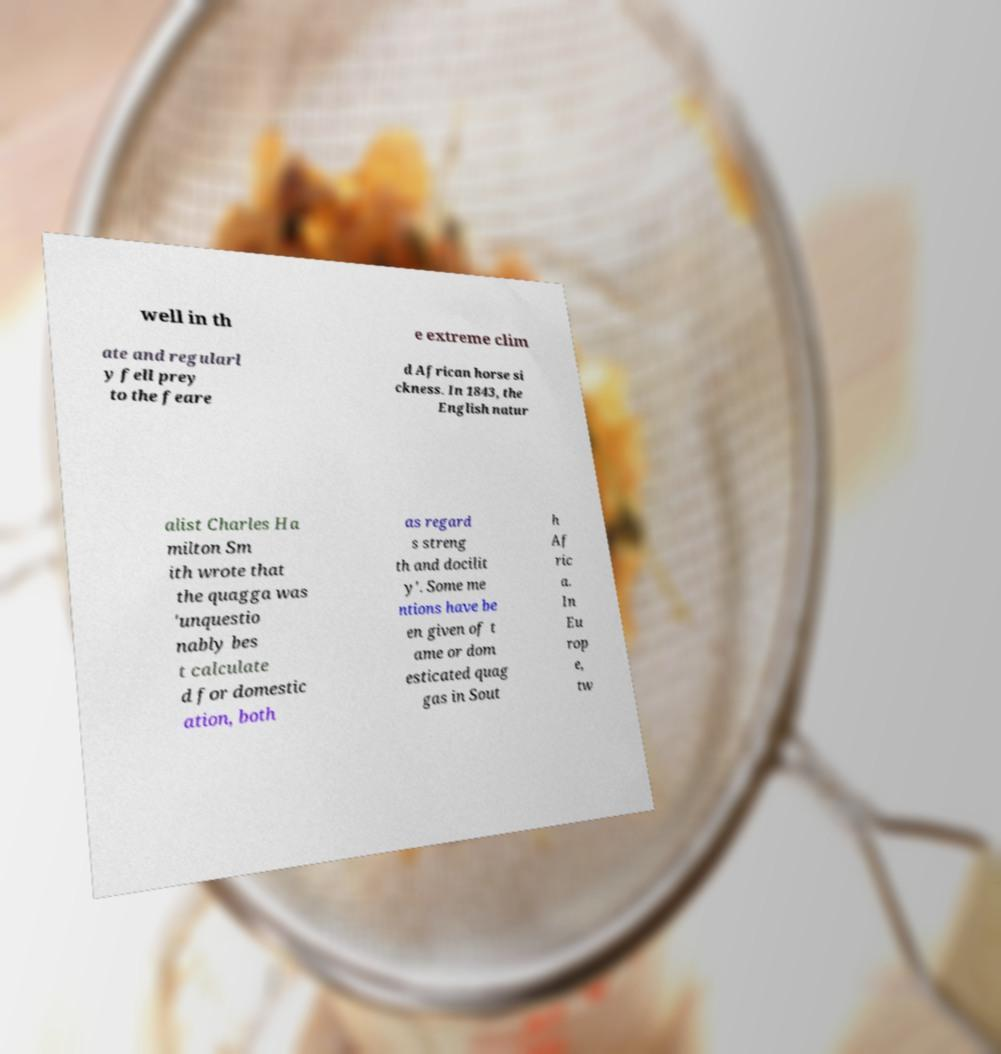Can you accurately transcribe the text from the provided image for me? well in th e extreme clim ate and regularl y fell prey to the feare d African horse si ckness. In 1843, the English natur alist Charles Ha milton Sm ith wrote that the quagga was 'unquestio nably bes t calculate d for domestic ation, both as regard s streng th and docilit y'. Some me ntions have be en given of t ame or dom esticated quag gas in Sout h Af ric a. In Eu rop e, tw 